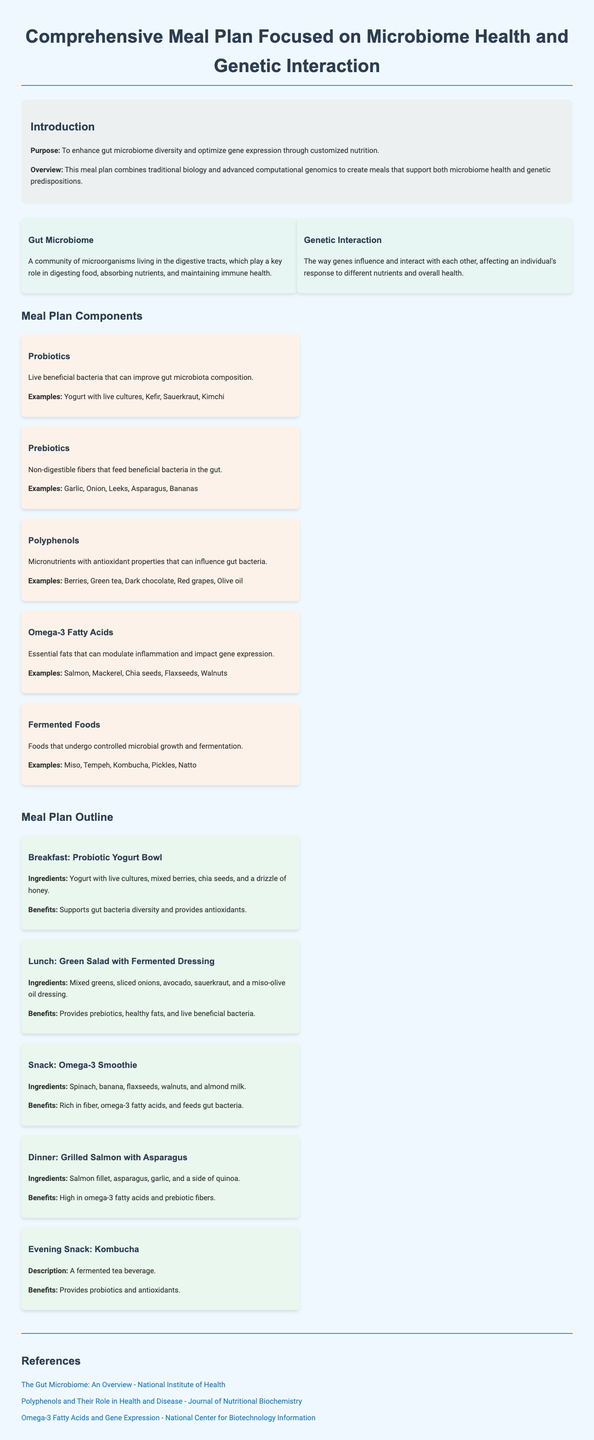What is the main purpose of the meal plan? The main purpose is to enhance gut microbiome diversity and optimize gene expression through customized nutrition.
Answer: Enhance gut microbiome diversity and optimize gene expression What are probiotics? Probiotics are live beneficial bacteria that can improve gut microbiota composition.
Answer: Live beneficial bacteria Which ingredient in the breakfast supports antioxidants? Mixed berries provide antioxidants in the Probiotic Yogurt Bowl.
Answer: Mixed berries How many main meals are included in this meal plan? There are five main meals included in the meal plan.
Answer: Five What is the benefit of the Omega-3 Smoothie? The benefit of the Omega-3 Smoothie is that it is rich in fiber, omega-3 fatty acids, and feeds gut bacteria.
Answer: Rich in fiber, omega-3 fatty acids, and feeds gut bacteria Which food undergoes controlled microbial growth and fermentation? Fermented foods undergo controlled microbial growth and fermentation.
Answer: Fermented foods What does the 'Evening Snack' consist of? The Evening Snack consists of Kombucha, which is a fermented tea beverage.
Answer: Kombucha What example of prebiotics is mentioned? Garlic is mentioned as an example of prebiotics.
Answer: Garlic What nutritional components are aimed at impacting gene expression? Omega-3 fatty acids are aimed at impacting gene expression.
Answer: Omega-3 fatty acids 